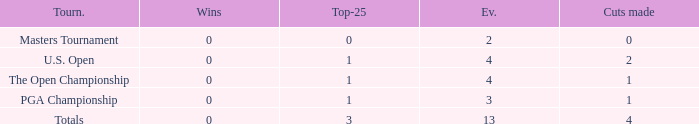How many cuts did he make at the PGA championship in 3 events? None. Could you parse the entire table? {'header': ['Tourn.', 'Wins', 'Top-25', 'Ev.', 'Cuts made'], 'rows': [['Masters Tournament', '0', '0', '2', '0'], ['U.S. Open', '0', '1', '4', '2'], ['The Open Championship', '0', '1', '4', '1'], ['PGA Championship', '0', '1', '3', '1'], ['Totals', '0', '3', '13', '4']]} 